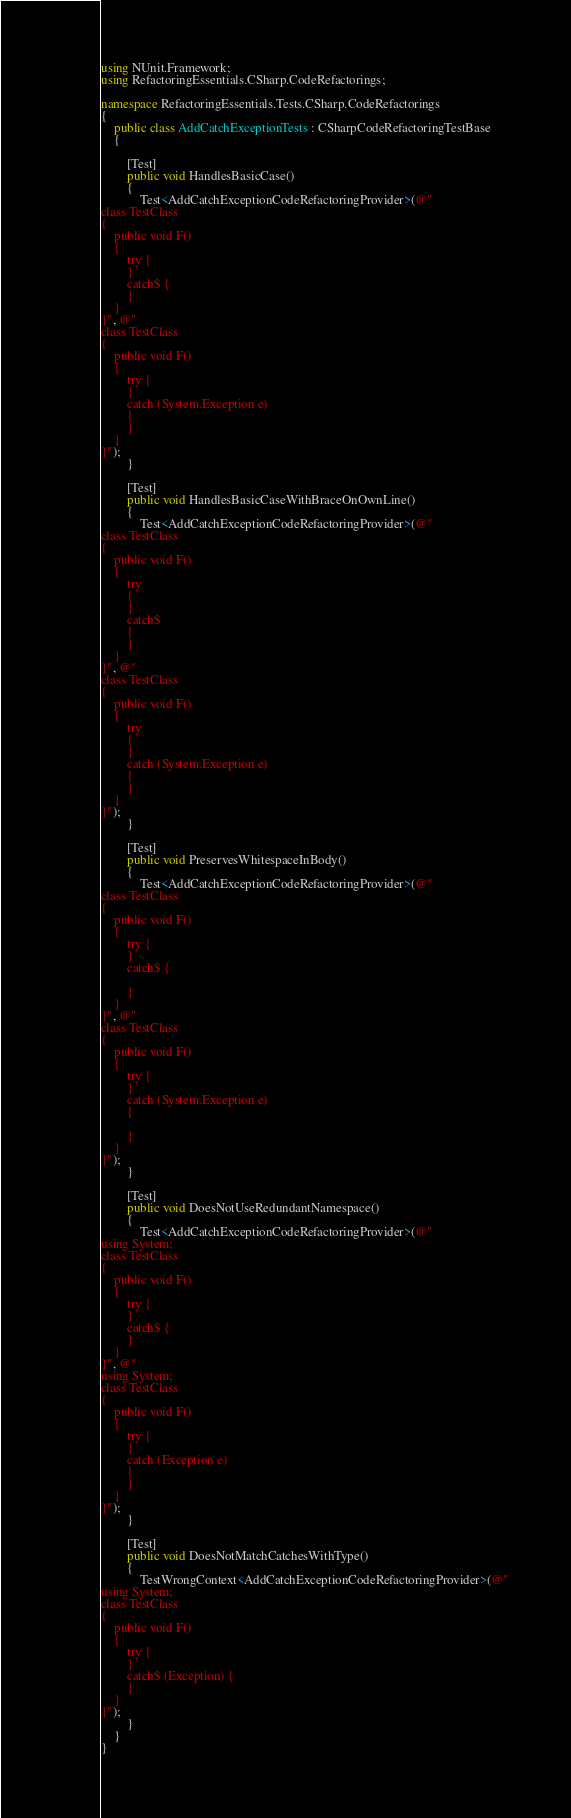<code> <loc_0><loc_0><loc_500><loc_500><_C#_>using NUnit.Framework;
using RefactoringEssentials.CSharp.CodeRefactorings;

namespace RefactoringEssentials.Tests.CSharp.CodeRefactorings
{
    public class AddCatchExceptionTests : CSharpCodeRefactoringTestBase
    {

        [Test]
        public void HandlesBasicCase()
        {
            Test<AddCatchExceptionCodeRefactoringProvider>(@"
class TestClass
{
    public void F()
    {
        try {
        }
        catch$ {
        }
    }
}", @"
class TestClass
{
    public void F()
    {
        try {
        }
        catch (System.Exception e)
        {
        }
    }
}");
        }

        [Test]
        public void HandlesBasicCaseWithBraceOnOwnLine()
        {
            Test<AddCatchExceptionCodeRefactoringProvider>(@"
class TestClass
{
    public void F()
    {
        try
        {
        }
        catch$
        {
        }
    }
}", @"
class TestClass
{
    public void F()
    {
        try
        {
        }
        catch (System.Exception e)
        {
        }
    }
}");
        }

        [Test]
        public void PreservesWhitespaceInBody()
        {
            Test<AddCatchExceptionCodeRefactoringProvider>(@"
class TestClass
{
    public void F()
    {
        try {
        }
        catch$ {

        }
    }
}", @"
class TestClass
{
    public void F()
    {
        try {
        }
        catch (System.Exception e)
        {

        }
    }
}");
        }

        [Test]
        public void DoesNotUseRedundantNamespace()
        {
            Test<AddCatchExceptionCodeRefactoringProvider>(@"
using System;
class TestClass
{
    public void F()
    {
        try {
        }
        catch$ {
        }
    }
}", @"
using System;
class TestClass
{
    public void F()
    {
        try {
        }
        catch (Exception e)
        {
        }
    }
}");
        }

        [Test]
        public void DoesNotMatchCatchesWithType()
        {
            TestWrongContext<AddCatchExceptionCodeRefactoringProvider>(@"
using System;
class TestClass
{
    public void F()
    {
        try {
        }
        catch$ (Exception) {
        }
    }
}");
        }
    }
}
</code> 